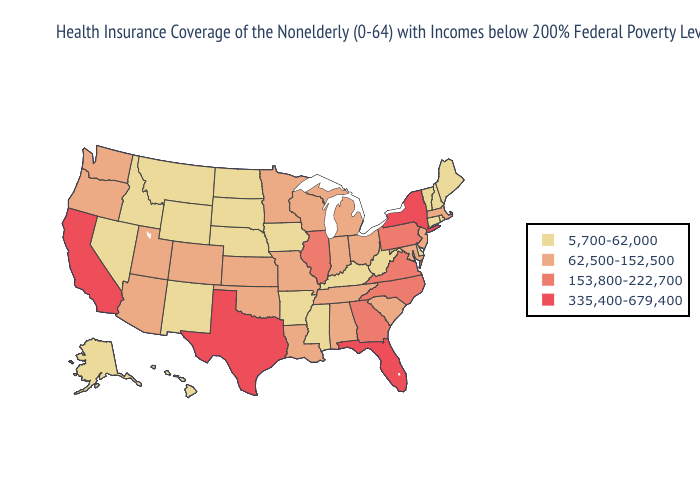Does Kansas have the same value as Massachusetts?
Write a very short answer. Yes. Does Georgia have the highest value in the USA?
Concise answer only. No. What is the highest value in states that border Oklahoma?
Give a very brief answer. 335,400-679,400. What is the value of Maryland?
Answer briefly. 62,500-152,500. Does Pennsylvania have the lowest value in the Northeast?
Answer briefly. No. What is the value of Michigan?
Be succinct. 62,500-152,500. Does Hawaii have the lowest value in the USA?
Quick response, please. Yes. What is the lowest value in states that border Florida?
Be succinct. 62,500-152,500. What is the value of South Dakota?
Write a very short answer. 5,700-62,000. Which states have the lowest value in the West?
Keep it brief. Alaska, Hawaii, Idaho, Montana, Nevada, New Mexico, Wyoming. Is the legend a continuous bar?
Short answer required. No. Does Kentucky have the highest value in the USA?
Be succinct. No. Name the states that have a value in the range 62,500-152,500?
Give a very brief answer. Alabama, Arizona, Colorado, Indiana, Kansas, Louisiana, Maryland, Massachusetts, Michigan, Minnesota, Missouri, New Jersey, Ohio, Oklahoma, Oregon, South Carolina, Tennessee, Utah, Washington, Wisconsin. What is the lowest value in the USA?
Quick response, please. 5,700-62,000. What is the value of New Hampshire?
Short answer required. 5,700-62,000. 